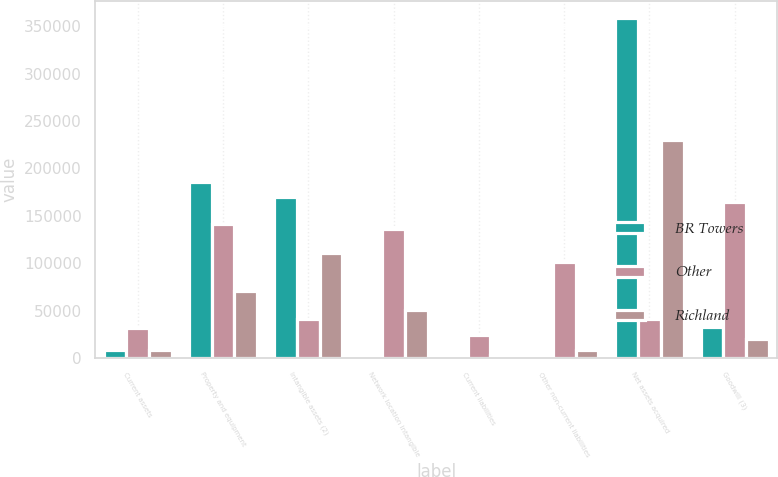Convert chart. <chart><loc_0><loc_0><loc_500><loc_500><stacked_bar_chart><ecel><fcel>Current assets<fcel>Property and equipment<fcel>Intangible assets (2)<fcel>Network location intangible<fcel>Current liabilities<fcel>Other non-current liabilities<fcel>Net assets acquired<fcel>Goodwill (3)<nl><fcel>BR Towers<fcel>8583<fcel>185777<fcel>169452<fcel>1700<fcel>3635<fcel>2922<fcel>358955<fcel>32423<nl><fcel>Other<fcel>31832<fcel>141422<fcel>41311<fcel>136233<fcel>23930<fcel>101508<fcel>41311<fcel>164955<nl><fcel>Richland<fcel>7869<fcel>70638<fcel>110207<fcel>50199<fcel>2860<fcel>7938<fcel>229636<fcel>19835<nl></chart> 